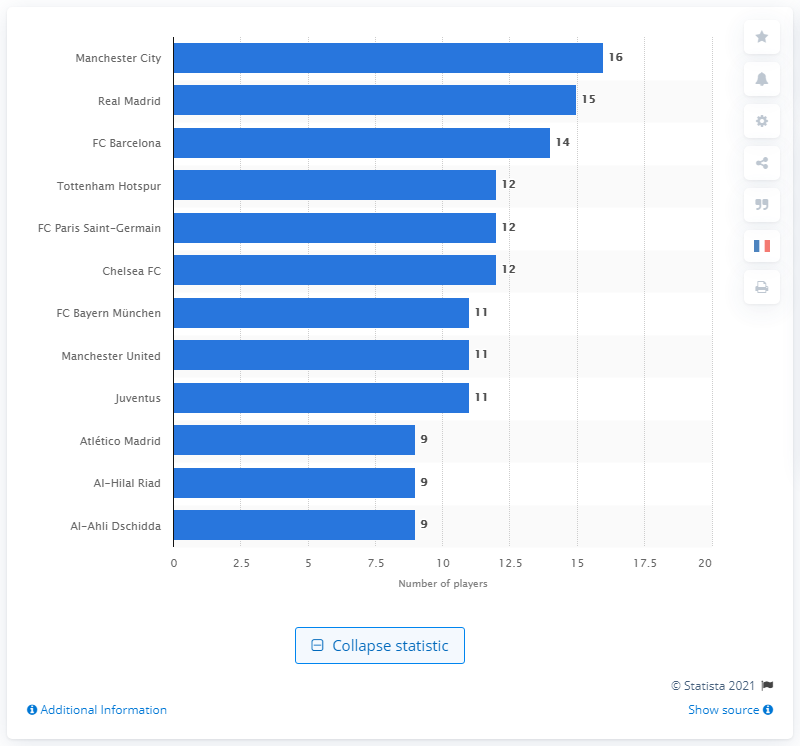List a handful of essential elements in this visual. Of Manchester City's players, 16 participated in the 2018 World Cup. Manchester City was the most represented team at the 2018 World Cup. 